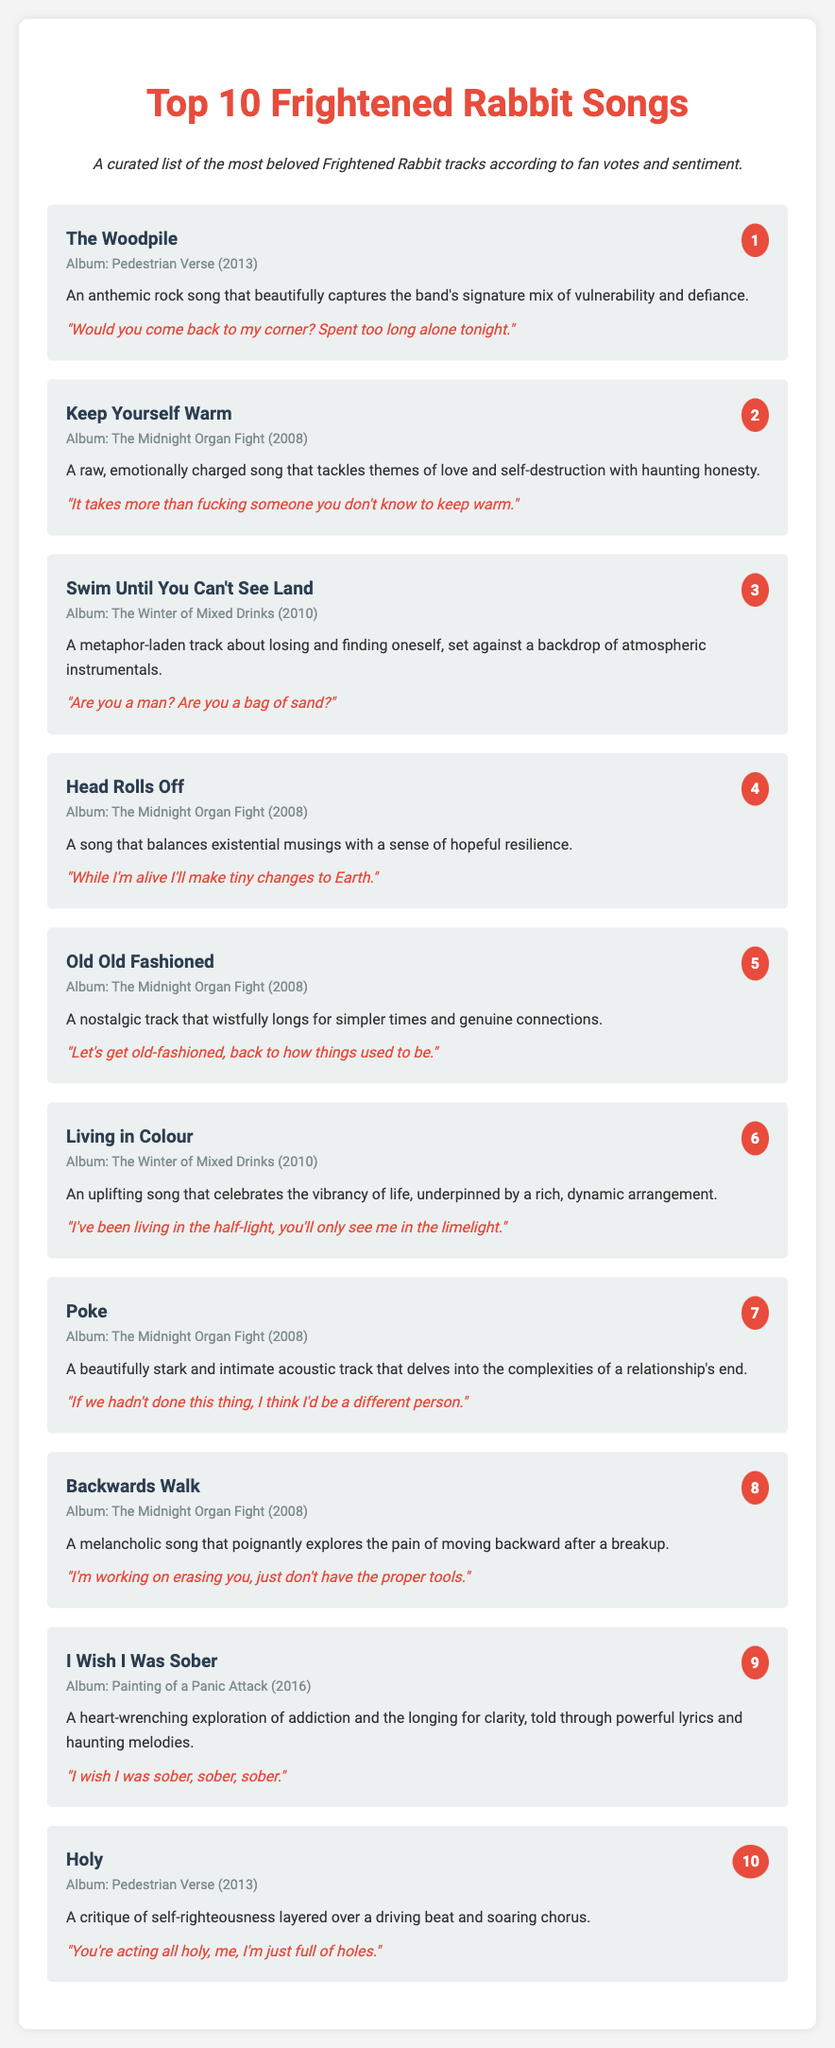what is the title of the top-ranked song? The title of the top-ranked song is given clearly in the document as "The Woodpile."
Answer: The Woodpile which album features "Keep Yourself Warm"? "Keep Yourself Warm" is associated with the album "The Midnight Organ Fight" as stated in the song information.
Answer: The Midnight Organ Fight how many songs are listed in total? The document lists a total of 10 songs ranked by fans.
Answer: 10 what theme is explored in "I Wish I Was Sober"? The song "I Wish I Was Sober" explores the theme of addiction and longing for clarity.
Answer: Addiction which song has the lyric "Would you come back to my corner?" The lyric is from the song ranked number one, "The Woodpile."
Answer: The Woodpile what is the rank of "Poke"? "Poke" is ranked number 7 in the list of songs.
Answer: 7 which song features lyrics about self-destruction? "Keep Yourself Warm" features lyrics that tackle themes of love and self-destruction.
Answer: Keep Yourself Warm what is the lyrical quote from "Head Rolls Off"? The quoted lyric from "Head Rolls Off" is "While I'm alive I'll make tiny changes to Earth."
Answer: While I'm alive I'll make tiny changes to Earth which song critiques self-righteousness? The song that critiques self-righteousness is "Holy."
Answer: Holy 